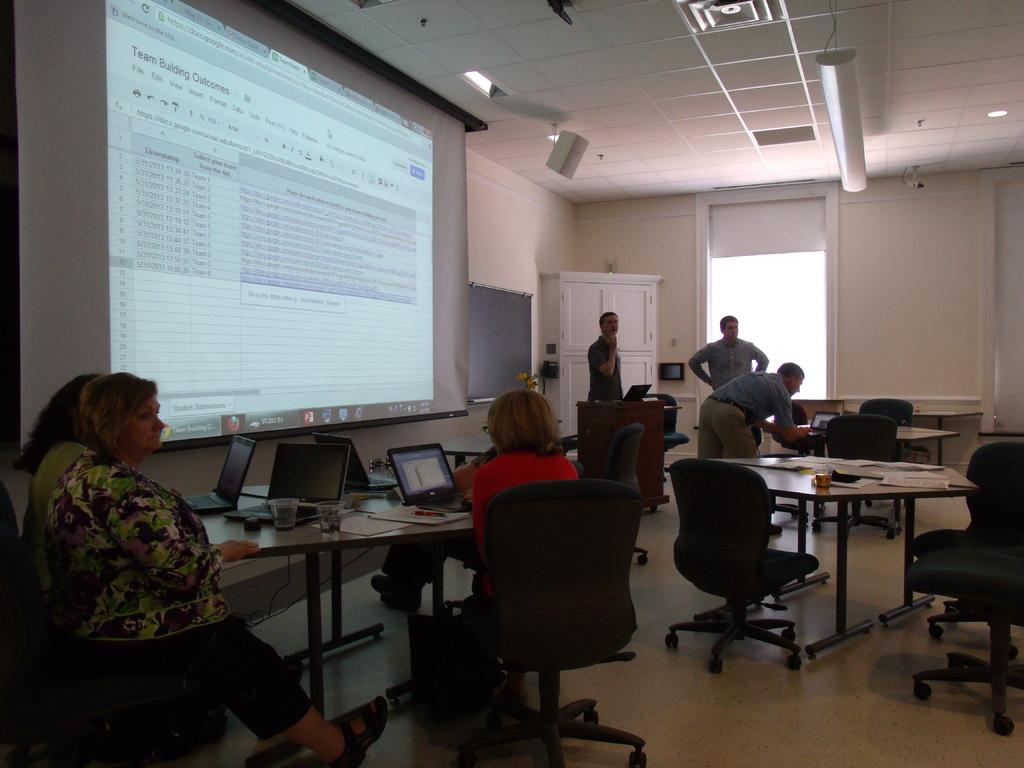What are the people in the image doing? The people in the image are seated and using laptops. What is the purpose of the table in the image? The table is likely used for holding the laptops and other items. How many men are standing in the image? There are three men standing in the image. What is the large screen in the image used for? The large screen in the image is a projector screen, which is likely used for displaying presentations or other visual aids. What type of furniture is visible in the image? Chairs and tables are visible in the image. What type of scarf is draped over the projector screen in the image? There is no scarf present on the projector screen in the image. How many cans of soda are visible on the table in the image? There is no mention of cans of soda in the image; only a table, laptops, and a projector screen are described. 